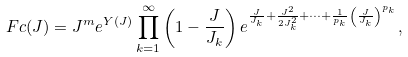<formula> <loc_0><loc_0><loc_500><loc_500>\ F c ( J ) = J ^ { m } e ^ { Y ( J ) } \prod _ { k = 1 } ^ { \infty } \left ( 1 - \frac { J } { J _ { k } } \right ) e ^ { \frac { J } { J _ { k } } + \frac { J ^ { 2 } } { 2 J _ { k } ^ { 2 } } + \dots + \frac { 1 } { p _ { k } } \left ( \frac { J } { J _ { k } } \right ) ^ { p _ { k } } } ,</formula> 